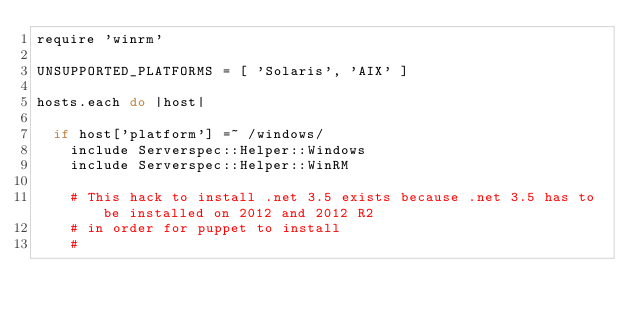Convert code to text. <code><loc_0><loc_0><loc_500><loc_500><_Ruby_>require 'winrm'

UNSUPPORTED_PLATFORMS = [ 'Solaris', 'AIX' ]

hosts.each do |host|

  if host['platform'] =~ /windows/
    include Serverspec::Helper::Windows
    include Serverspec::Helper::WinRM

    # This hack to install .net 3.5 exists because .net 3.5 has to be installed on 2012 and 2012 R2
    # in order for puppet to install
    #</code> 